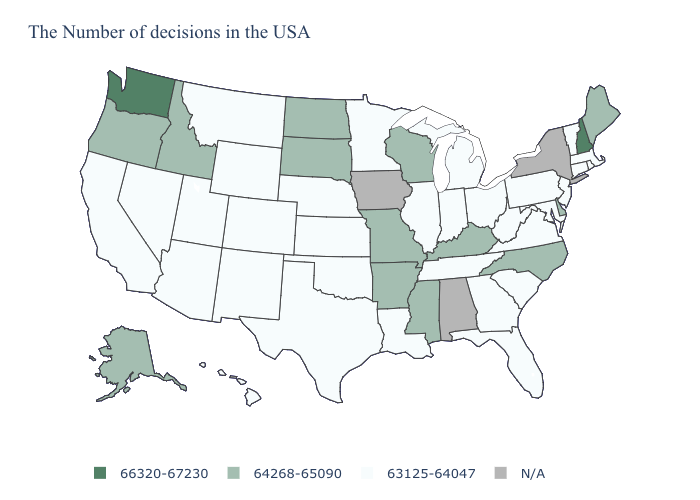Which states have the lowest value in the USA?
Quick response, please. Massachusetts, Rhode Island, Vermont, Connecticut, New Jersey, Maryland, Pennsylvania, Virginia, South Carolina, West Virginia, Ohio, Florida, Georgia, Michigan, Indiana, Tennessee, Illinois, Louisiana, Minnesota, Kansas, Nebraska, Oklahoma, Texas, Wyoming, Colorado, New Mexico, Utah, Montana, Arizona, Nevada, California, Hawaii. Among the states that border Nevada , which have the lowest value?
Write a very short answer. Utah, Arizona, California. What is the value of Nevada?
Concise answer only. 63125-64047. What is the lowest value in the USA?
Be succinct. 63125-64047. What is the value of South Dakota?
Keep it brief. 64268-65090. What is the value of Wyoming?
Be succinct. 63125-64047. Name the states that have a value in the range 63125-64047?
Short answer required. Massachusetts, Rhode Island, Vermont, Connecticut, New Jersey, Maryland, Pennsylvania, Virginia, South Carolina, West Virginia, Ohio, Florida, Georgia, Michigan, Indiana, Tennessee, Illinois, Louisiana, Minnesota, Kansas, Nebraska, Oklahoma, Texas, Wyoming, Colorado, New Mexico, Utah, Montana, Arizona, Nevada, California, Hawaii. Name the states that have a value in the range 63125-64047?
Answer briefly. Massachusetts, Rhode Island, Vermont, Connecticut, New Jersey, Maryland, Pennsylvania, Virginia, South Carolina, West Virginia, Ohio, Florida, Georgia, Michigan, Indiana, Tennessee, Illinois, Louisiana, Minnesota, Kansas, Nebraska, Oklahoma, Texas, Wyoming, Colorado, New Mexico, Utah, Montana, Arizona, Nevada, California, Hawaii. Does the first symbol in the legend represent the smallest category?
Answer briefly. No. Which states have the highest value in the USA?
Give a very brief answer. New Hampshire, Washington. Does New Hampshire have the highest value in the Northeast?
Concise answer only. Yes. Among the states that border Georgia , does Tennessee have the lowest value?
Be succinct. Yes. 